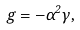Convert formula to latex. <formula><loc_0><loc_0><loc_500><loc_500>g = - \alpha ^ { 2 } \gamma ,</formula> 